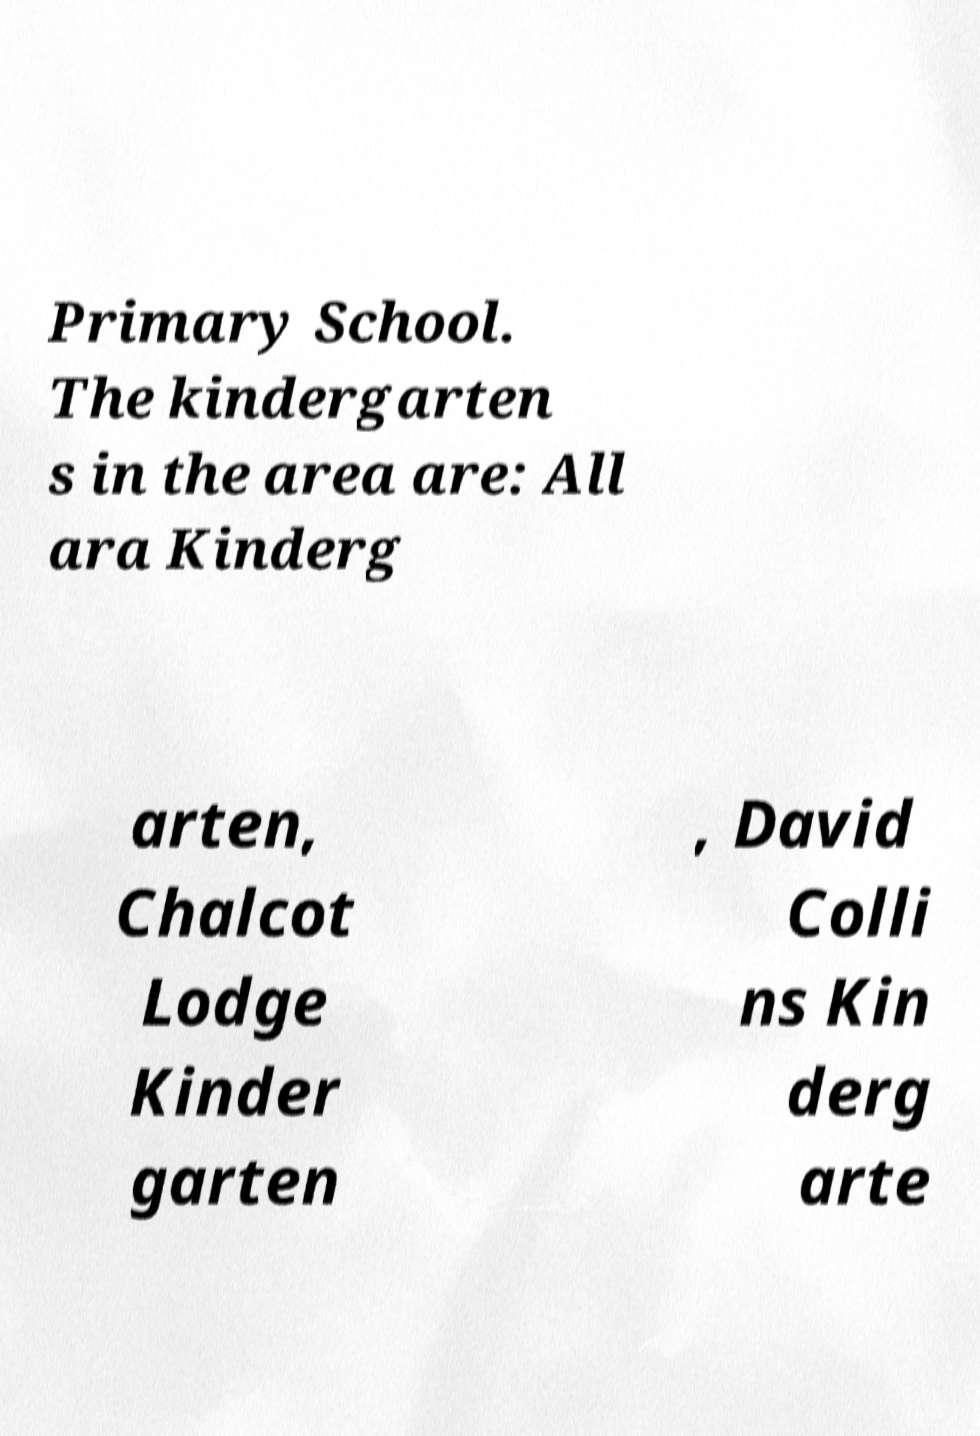Could you assist in decoding the text presented in this image and type it out clearly? Primary School. The kindergarten s in the area are: All ara Kinderg arten, Chalcot Lodge Kinder garten , David Colli ns Kin derg arte 